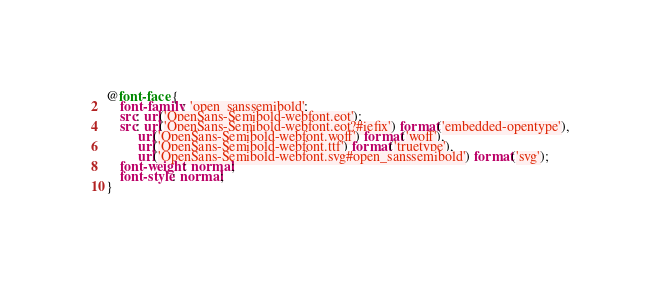Convert code to text. <code><loc_0><loc_0><loc_500><loc_500><_CSS_>@font-face {
    font-family: 'open_sanssemibold';
    src: url('OpenSans-Semibold-webfont.eot');
    src: url('OpenSans-Semibold-webfont.eot?#iefix') format('embedded-opentype'),
         url('OpenSans-Semibold-webfont.woff') format('woff'),
         url('OpenSans-Semibold-webfont.ttf') format('truetype'),
         url('OpenSans-Semibold-webfont.svg#open_sanssemibold') format('svg');
    font-weight: normal;
    font-style: normal;
}
</code> 